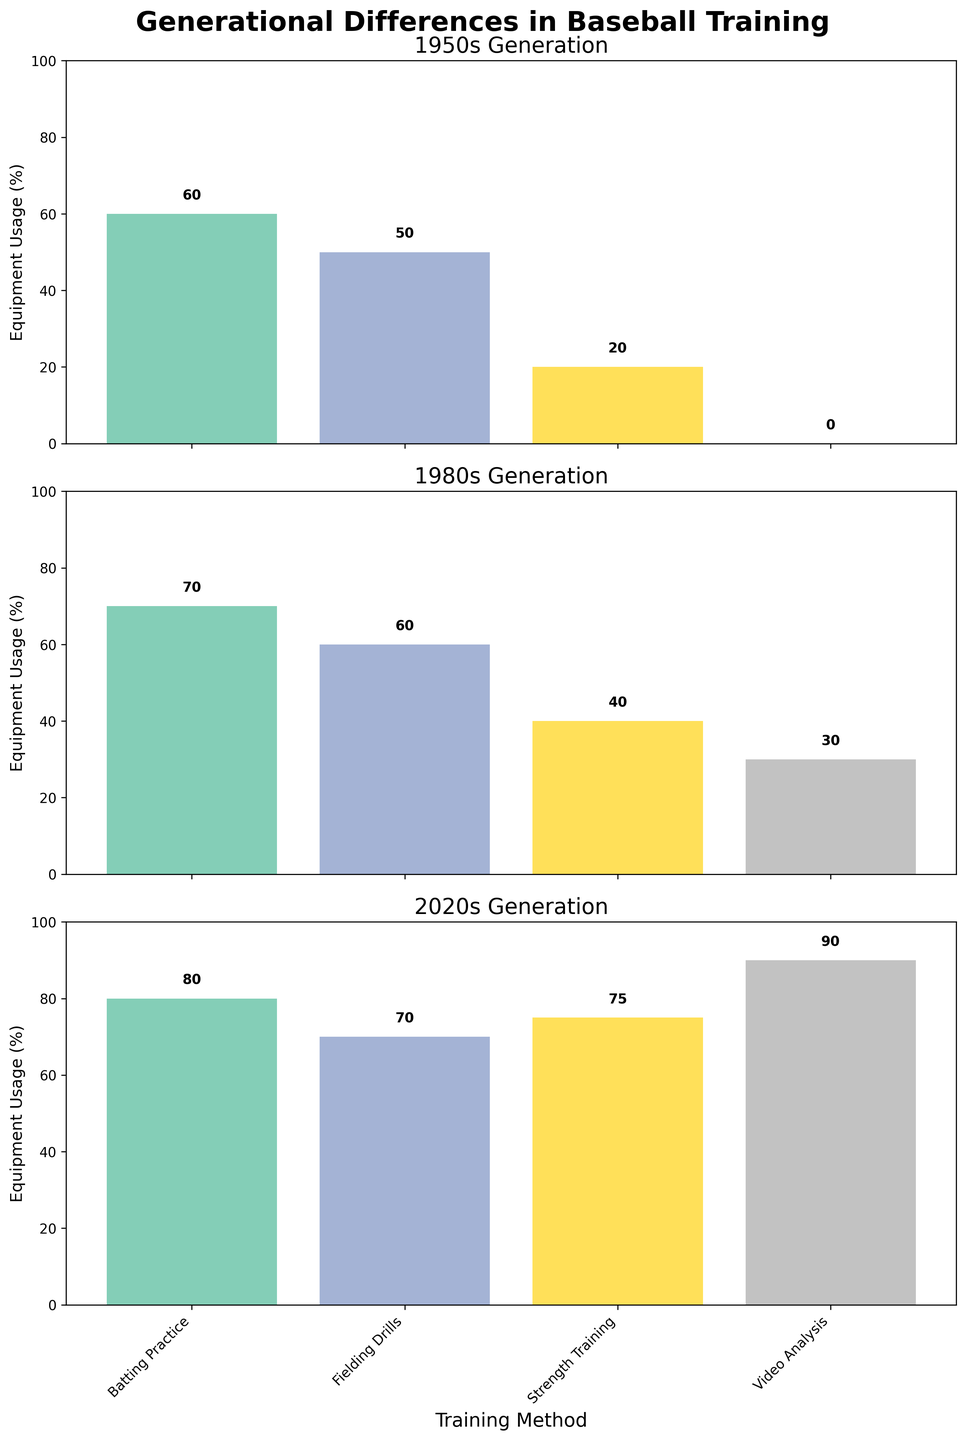What is the title of the figure? The title is displayed at the top of the figure and summarizes what the visual is about.
Answer: Generational Differences in Baseball Training Which generation had the lowest usage of strength training equipment? To determine this, look at the relative height of the bars labeled as 'Strength Training' for each generation.
Answer: 1950s What is the difference in equipment usage for video analysis between the 1950s and 2020s? To find the difference, subtract the value for video analysis in the 1950s (0%) from the value for the 2020s (90%).
Answer: 90% Which training method saw the largest increase in equipment usage from the 1980s to the 2020s? Compare the increase in height of the bars for each training method between the two generations.
Answer: Strength Training Identify the generation with the highest overall usage percentage for fielding drills. To identify this, compare the heights of the 'Fielding Drills' bars across generations and see which one is the tallest.
Answer: 2020s How many training methods have an equipment usage of at least 70% in the 2020s? Count all bars in the 2020s subplot that meet or exceed 70%.
Answer: 3 Which generation relies the least on video analysis? By examining the height of the 'Video Analysis' bar for each generation, find the lowest one.
Answer: 1950s What is the average equipment usage for all training methods in the 1950s generation? Add up all the usage percentages for the 1950s and divide by the number of methods: (60 + 50 + 20 + 0) / 4 = 32.5%
Answer: 32.5% Compare the usage of batting practice equipment in the 1980s and 2020s. Which generation utilized it more? Examine the height of the batting practice bars for both the 1980s and the 2020s and compare them.
Answer: 2020s What's the total usage percentage of equipment for strength training across all generations? Sum the values for strength training in the 1950s (20), 1980s (40), and 2020s (75): 20 + 40 + 75 = 135%.
Answer: 135% 